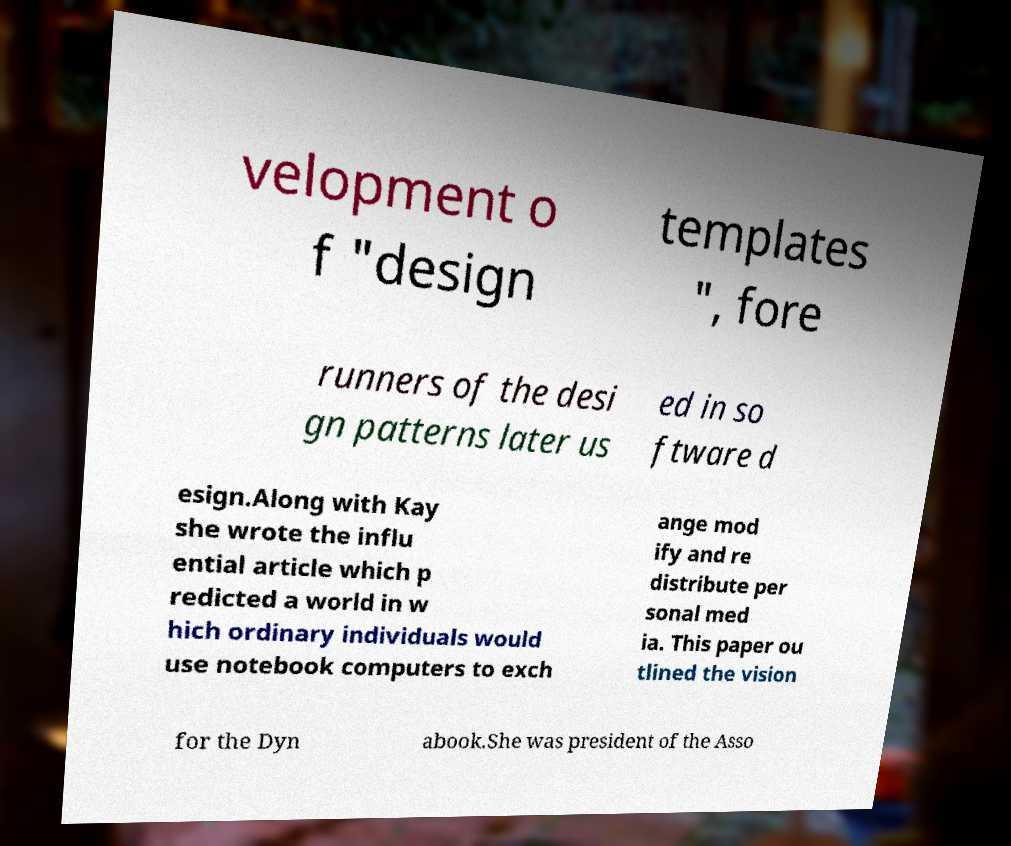What messages or text are displayed in this image? I need them in a readable, typed format. velopment o f "design templates ", fore runners of the desi gn patterns later us ed in so ftware d esign.Along with Kay she wrote the influ ential article which p redicted a world in w hich ordinary individuals would use notebook computers to exch ange mod ify and re distribute per sonal med ia. This paper ou tlined the vision for the Dyn abook.She was president of the Asso 